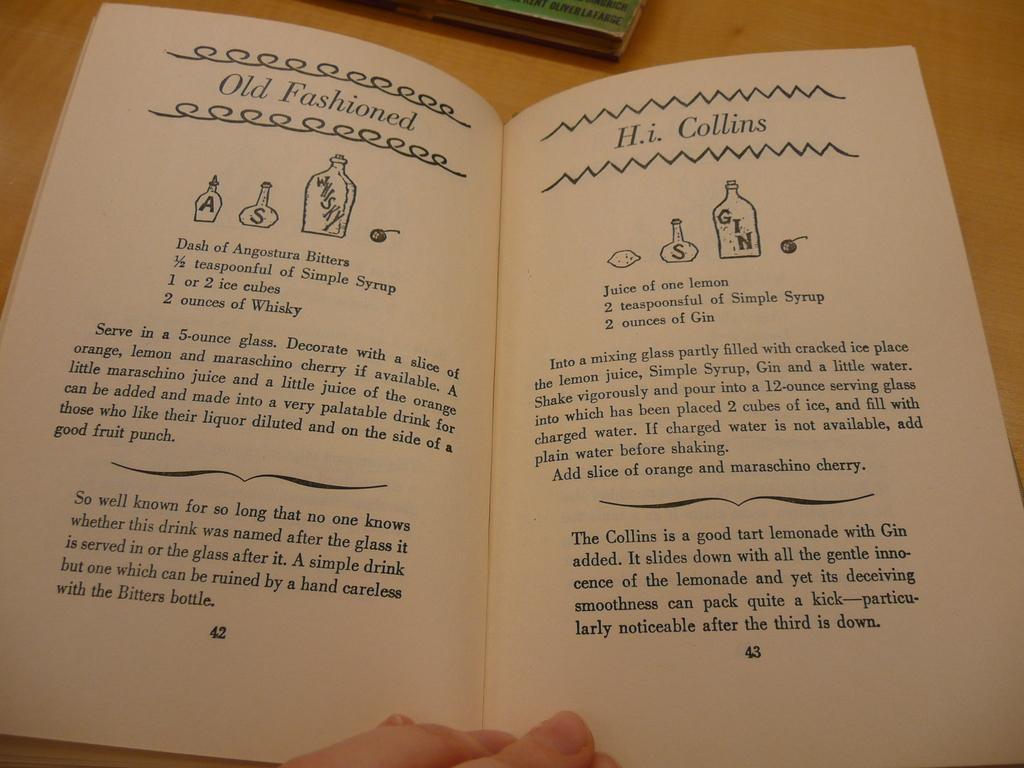<image>
Describe the image concisely. a book of drink recipes is open to the page with an Old fashioned recipe 